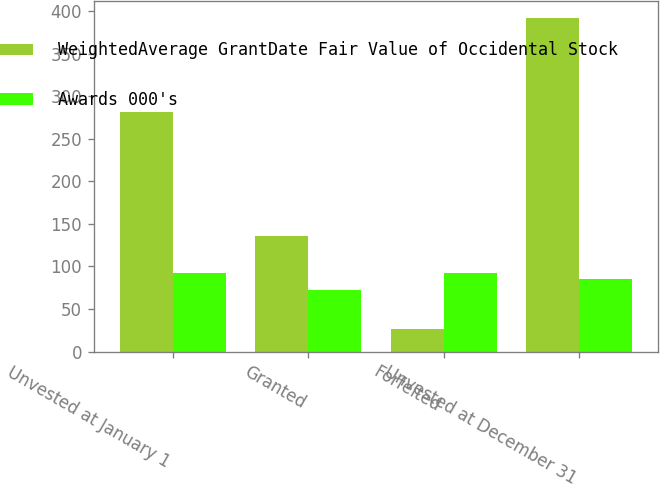Convert chart to OTSL. <chart><loc_0><loc_0><loc_500><loc_500><stacked_bar_chart><ecel><fcel>Unvested at January 1<fcel>Granted<fcel>Forfeited<fcel>Unvested at December 31<nl><fcel>WeightedAverage GrantDate Fair Value of Occidental Stock<fcel>282<fcel>136<fcel>26<fcel>392<nl><fcel>Awards 000's<fcel>92.25<fcel>72.54<fcel>91.98<fcel>85.43<nl></chart> 